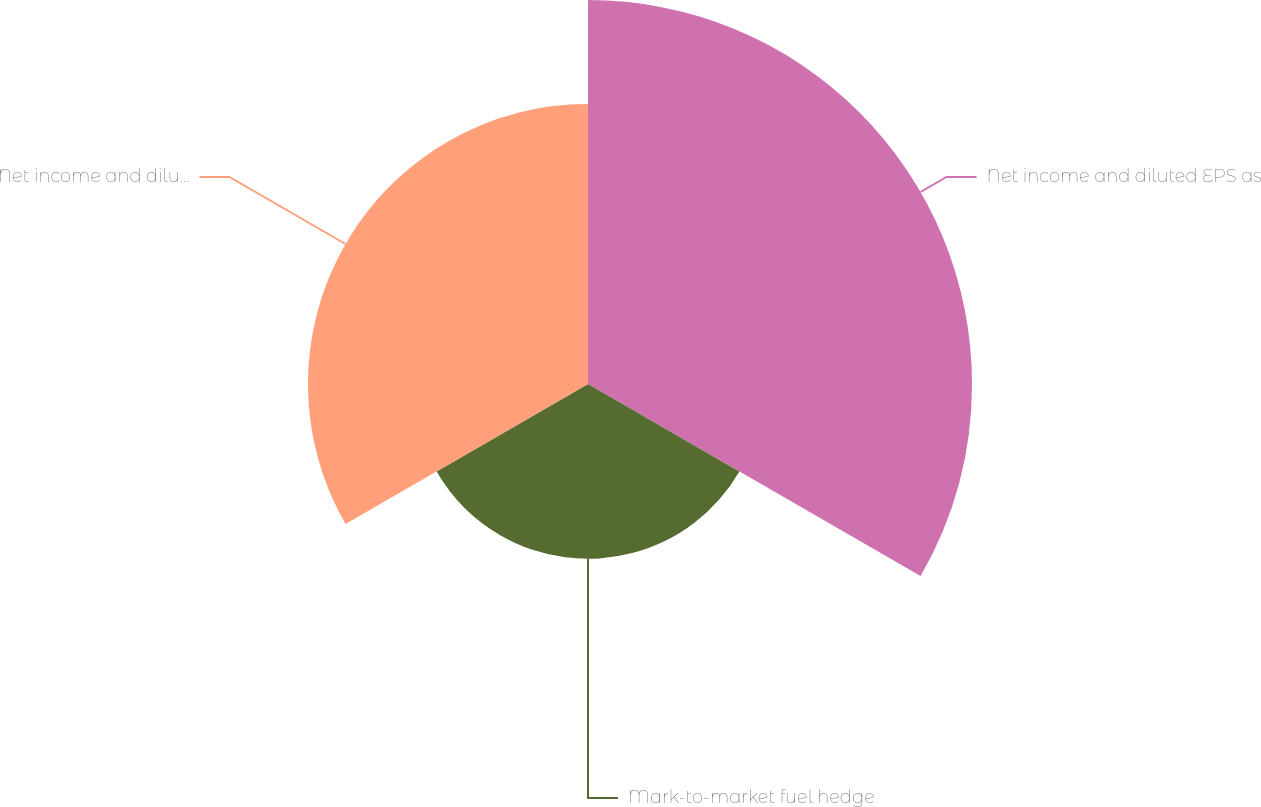Convert chart. <chart><loc_0><loc_0><loc_500><loc_500><pie_chart><fcel>Net income and diluted EPS as<fcel>Mark-to-market fuel hedge<fcel>Net income and diluted EPS<nl><fcel>45.78%<fcel>20.84%<fcel>33.38%<nl></chart> 